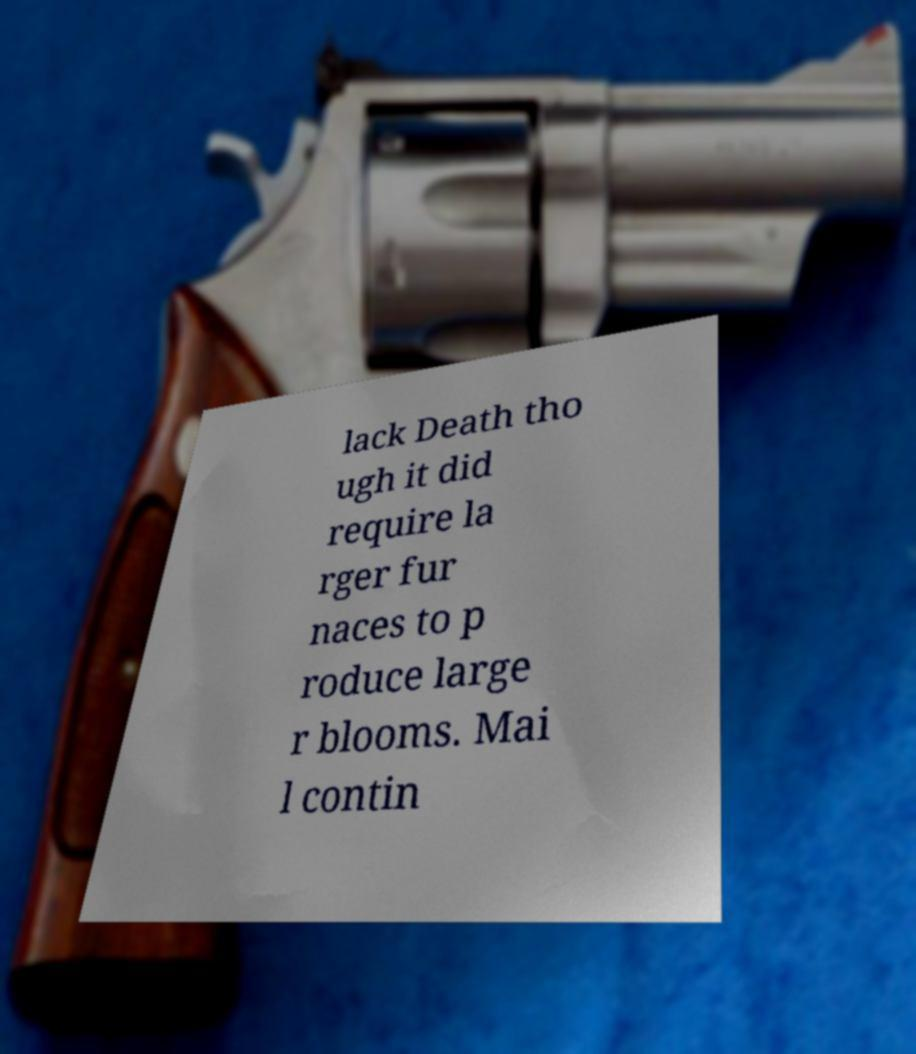Can you read and provide the text displayed in the image?This photo seems to have some interesting text. Can you extract and type it out for me? lack Death tho ugh it did require la rger fur naces to p roduce large r blooms. Mai l contin 